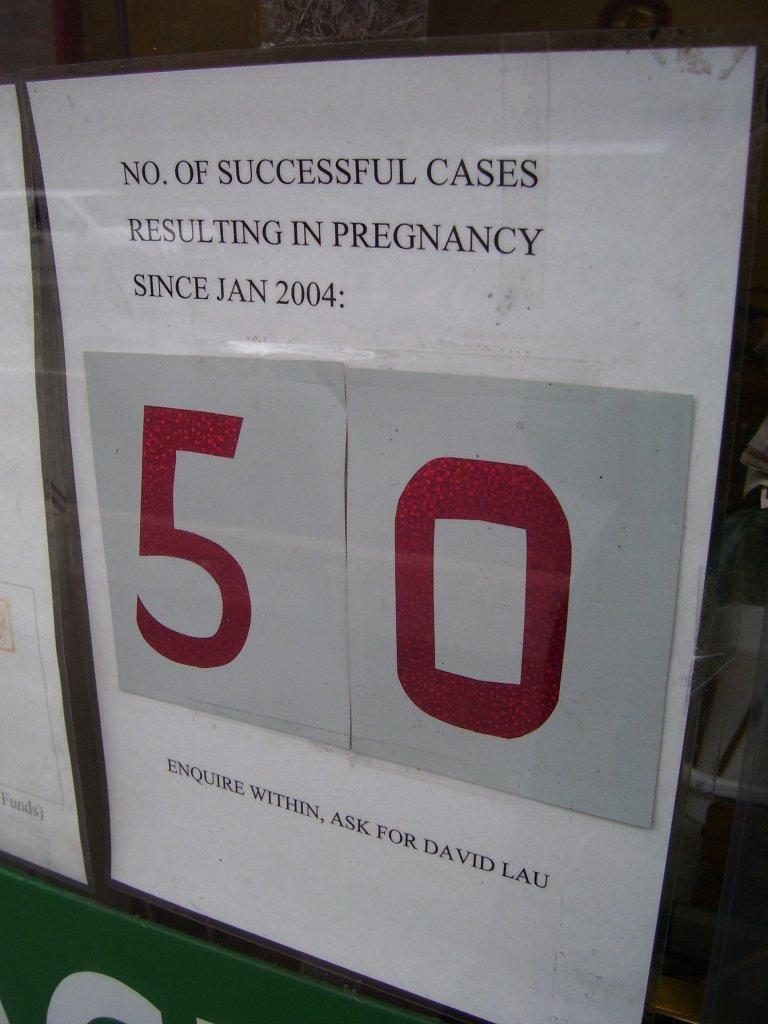Provide a one-sentence caption for the provided image. A sign stating 50 is the number of successful cases resulting in pregnancy since January 2004. 